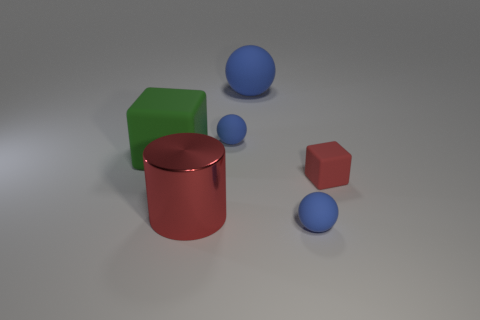Is the number of cubes that are left of the big blue matte object less than the number of red matte things left of the large metal object?
Offer a very short reply. No. What number of large gray blocks are there?
Ensure brevity in your answer.  0. What color is the matte ball that is in front of the big block?
Offer a terse response. Blue. How big is the red matte block?
Your answer should be very brief. Small. Do the tiny rubber cube and the matte object that is on the left side of the cylinder have the same color?
Give a very brief answer. No. What color is the cube that is to the left of the red object that is behind the large red shiny cylinder?
Provide a short and direct response. Green. Are there any other things that are the same size as the red rubber block?
Your response must be concise. Yes. Does the tiny blue rubber object to the left of the big blue matte object have the same shape as the large green rubber object?
Provide a short and direct response. No. How many spheres are in front of the big green cube and behind the red matte object?
Keep it short and to the point. 0. The tiny rubber sphere behind the cube that is on the left side of the blue thing that is in front of the green cube is what color?
Your answer should be compact. Blue. 